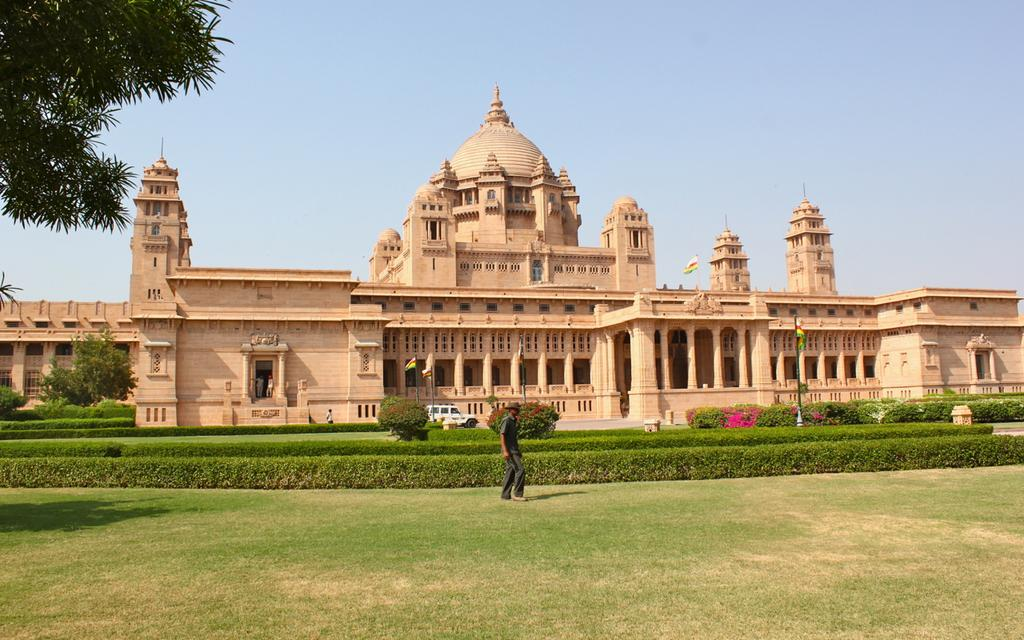What type of structure is visible in the image? There is a fort in the image. What type of vegetation can be seen in the image? There are trees, plants, and grass visible in the image. What is on the ground in the image? There is a vehicle on the ground in the image. What can be seen in the background of the image? There are flags and the sky visible in the background of the image. What is located on the right side of the image? There is a pole on the right side of the image. What type of cup is being used to paint the leg of the brush in the image? There is no cup, leg, or brush present in the image. 